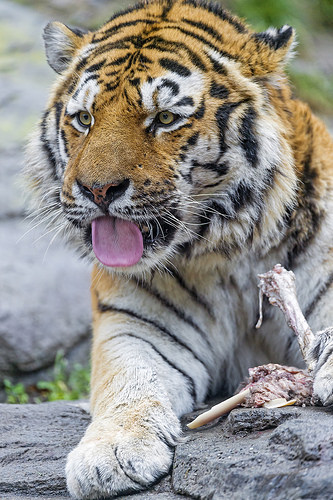<image>
Is there a tongue on the grass? No. The tongue is not positioned on the grass. They may be near each other, but the tongue is not supported by or resting on top of the grass. 